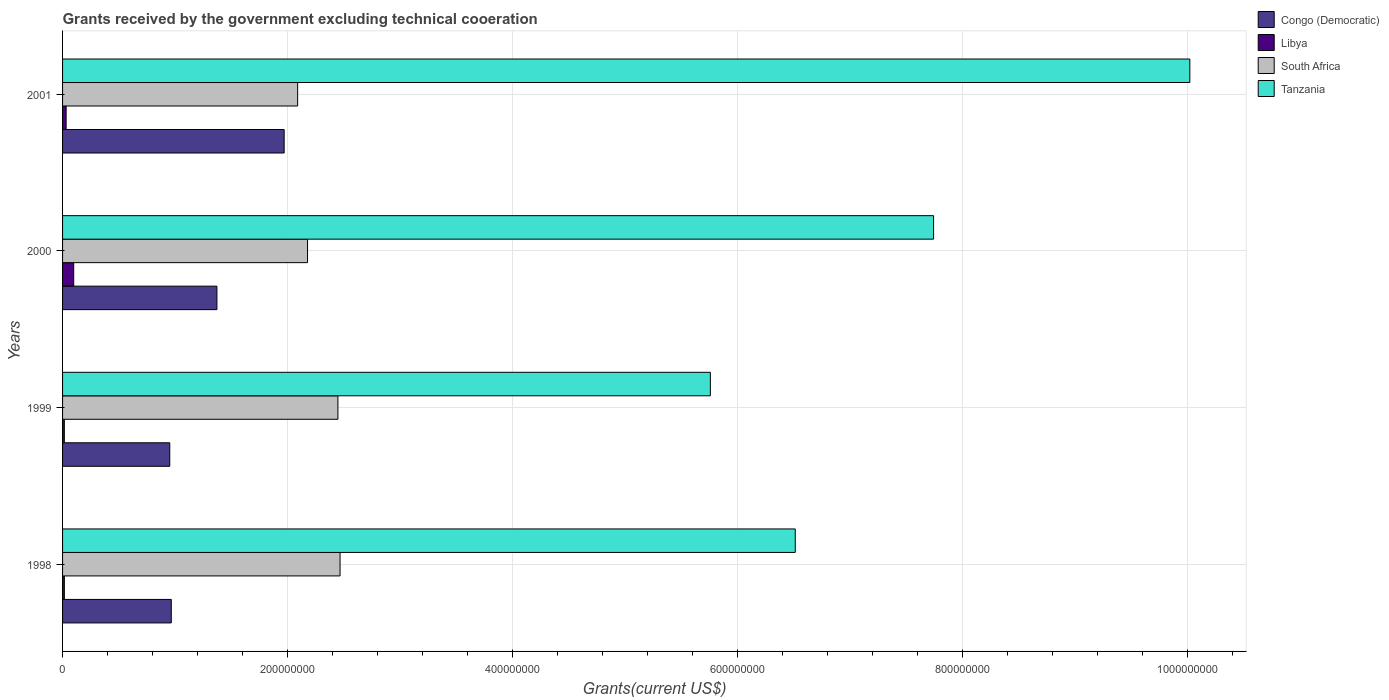How many groups of bars are there?
Offer a very short reply. 4. Are the number of bars per tick equal to the number of legend labels?
Offer a very short reply. Yes. How many bars are there on the 2nd tick from the top?
Offer a very short reply. 4. In how many cases, is the number of bars for a given year not equal to the number of legend labels?
Make the answer very short. 0. What is the total grants received by the government in Libya in 1999?
Ensure brevity in your answer.  1.57e+06. Across all years, what is the maximum total grants received by the government in Tanzania?
Offer a very short reply. 1.00e+09. Across all years, what is the minimum total grants received by the government in South Africa?
Make the answer very short. 2.09e+08. In which year was the total grants received by the government in Congo (Democratic) maximum?
Give a very brief answer. 2001. In which year was the total grants received by the government in Libya minimum?
Your response must be concise. 1999. What is the total total grants received by the government in Congo (Democratic) in the graph?
Provide a short and direct response. 5.26e+08. What is the difference between the total grants received by the government in Congo (Democratic) in 1999 and that in 2000?
Your response must be concise. -4.19e+07. What is the difference between the total grants received by the government in Congo (Democratic) in 1999 and the total grants received by the government in South Africa in 2001?
Provide a succinct answer. -1.14e+08. What is the average total grants received by the government in Libya per year?
Keep it short and to the point. 4.06e+06. In the year 1999, what is the difference between the total grants received by the government in Libya and total grants received by the government in Congo (Democratic)?
Provide a short and direct response. -9.37e+07. In how many years, is the total grants received by the government in Tanzania greater than 640000000 US$?
Your answer should be compact. 3. What is the ratio of the total grants received by the government in South Africa in 1999 to that in 2001?
Make the answer very short. 1.17. Is the difference between the total grants received by the government in Libya in 1999 and 2001 greater than the difference between the total grants received by the government in Congo (Democratic) in 1999 and 2001?
Keep it short and to the point. Yes. What is the difference between the highest and the second highest total grants received by the government in Congo (Democratic)?
Your answer should be very brief. 5.98e+07. What is the difference between the highest and the lowest total grants received by the government in Congo (Democratic)?
Your response must be concise. 1.02e+08. In how many years, is the total grants received by the government in Congo (Democratic) greater than the average total grants received by the government in Congo (Democratic) taken over all years?
Provide a succinct answer. 2. Is it the case that in every year, the sum of the total grants received by the government in Tanzania and total grants received by the government in Libya is greater than the sum of total grants received by the government in Congo (Democratic) and total grants received by the government in South Africa?
Offer a very short reply. Yes. What does the 1st bar from the top in 2000 represents?
Offer a very short reply. Tanzania. What does the 1st bar from the bottom in 1998 represents?
Make the answer very short. Congo (Democratic). Is it the case that in every year, the sum of the total grants received by the government in South Africa and total grants received by the government in Congo (Democratic) is greater than the total grants received by the government in Libya?
Make the answer very short. Yes. Are all the bars in the graph horizontal?
Provide a short and direct response. Yes. Does the graph contain any zero values?
Offer a very short reply. No. Does the graph contain grids?
Your answer should be compact. Yes. Where does the legend appear in the graph?
Offer a very short reply. Top right. What is the title of the graph?
Ensure brevity in your answer.  Grants received by the government excluding technical cooeration. Does "Madagascar" appear as one of the legend labels in the graph?
Your answer should be compact. No. What is the label or title of the X-axis?
Your answer should be very brief. Grants(current US$). What is the label or title of the Y-axis?
Make the answer very short. Years. What is the Grants(current US$) in Congo (Democratic) in 1998?
Keep it short and to the point. 9.67e+07. What is the Grants(current US$) in Libya in 1998?
Ensure brevity in your answer.  1.59e+06. What is the Grants(current US$) of South Africa in 1998?
Ensure brevity in your answer.  2.47e+08. What is the Grants(current US$) in Tanzania in 1998?
Offer a terse response. 6.51e+08. What is the Grants(current US$) of Congo (Democratic) in 1999?
Offer a terse response. 9.53e+07. What is the Grants(current US$) in Libya in 1999?
Your response must be concise. 1.57e+06. What is the Grants(current US$) in South Africa in 1999?
Your response must be concise. 2.45e+08. What is the Grants(current US$) of Tanzania in 1999?
Your answer should be compact. 5.76e+08. What is the Grants(current US$) of Congo (Democratic) in 2000?
Your answer should be compact. 1.37e+08. What is the Grants(current US$) in Libya in 2000?
Your response must be concise. 9.90e+06. What is the Grants(current US$) of South Africa in 2000?
Your answer should be very brief. 2.18e+08. What is the Grants(current US$) in Tanzania in 2000?
Offer a very short reply. 7.74e+08. What is the Grants(current US$) in Congo (Democratic) in 2001?
Ensure brevity in your answer.  1.97e+08. What is the Grants(current US$) in Libya in 2001?
Provide a short and direct response. 3.17e+06. What is the Grants(current US$) of South Africa in 2001?
Provide a succinct answer. 2.09e+08. What is the Grants(current US$) in Tanzania in 2001?
Give a very brief answer. 1.00e+09. Across all years, what is the maximum Grants(current US$) of Congo (Democratic)?
Your answer should be very brief. 1.97e+08. Across all years, what is the maximum Grants(current US$) of Libya?
Ensure brevity in your answer.  9.90e+06. Across all years, what is the maximum Grants(current US$) in South Africa?
Your answer should be very brief. 2.47e+08. Across all years, what is the maximum Grants(current US$) of Tanzania?
Provide a short and direct response. 1.00e+09. Across all years, what is the minimum Grants(current US$) of Congo (Democratic)?
Offer a terse response. 9.53e+07. Across all years, what is the minimum Grants(current US$) in Libya?
Make the answer very short. 1.57e+06. Across all years, what is the minimum Grants(current US$) of South Africa?
Offer a very short reply. 2.09e+08. Across all years, what is the minimum Grants(current US$) of Tanzania?
Ensure brevity in your answer.  5.76e+08. What is the total Grants(current US$) in Congo (Democratic) in the graph?
Make the answer very short. 5.26e+08. What is the total Grants(current US$) of Libya in the graph?
Keep it short and to the point. 1.62e+07. What is the total Grants(current US$) in South Africa in the graph?
Offer a very short reply. 9.18e+08. What is the total Grants(current US$) of Tanzania in the graph?
Make the answer very short. 3.00e+09. What is the difference between the Grants(current US$) in Congo (Democratic) in 1998 and that in 1999?
Your answer should be very brief. 1.35e+06. What is the difference between the Grants(current US$) of South Africa in 1998 and that in 1999?
Offer a terse response. 1.90e+06. What is the difference between the Grants(current US$) of Tanzania in 1998 and that in 1999?
Offer a very short reply. 7.55e+07. What is the difference between the Grants(current US$) in Congo (Democratic) in 1998 and that in 2000?
Offer a terse response. -4.06e+07. What is the difference between the Grants(current US$) of Libya in 1998 and that in 2000?
Keep it short and to the point. -8.31e+06. What is the difference between the Grants(current US$) of South Africa in 1998 and that in 2000?
Ensure brevity in your answer.  2.89e+07. What is the difference between the Grants(current US$) of Tanzania in 1998 and that in 2000?
Your response must be concise. -1.23e+08. What is the difference between the Grants(current US$) of Congo (Democratic) in 1998 and that in 2001?
Keep it short and to the point. -1.00e+08. What is the difference between the Grants(current US$) of Libya in 1998 and that in 2001?
Provide a short and direct response. -1.58e+06. What is the difference between the Grants(current US$) of South Africa in 1998 and that in 2001?
Give a very brief answer. 3.77e+07. What is the difference between the Grants(current US$) in Tanzania in 1998 and that in 2001?
Your answer should be compact. -3.51e+08. What is the difference between the Grants(current US$) in Congo (Democratic) in 1999 and that in 2000?
Your response must be concise. -4.19e+07. What is the difference between the Grants(current US$) in Libya in 1999 and that in 2000?
Provide a succinct answer. -8.33e+06. What is the difference between the Grants(current US$) in South Africa in 1999 and that in 2000?
Give a very brief answer. 2.70e+07. What is the difference between the Grants(current US$) in Tanzania in 1999 and that in 2000?
Your answer should be compact. -1.98e+08. What is the difference between the Grants(current US$) of Congo (Democratic) in 1999 and that in 2001?
Your answer should be compact. -1.02e+08. What is the difference between the Grants(current US$) of Libya in 1999 and that in 2001?
Provide a short and direct response. -1.60e+06. What is the difference between the Grants(current US$) in South Africa in 1999 and that in 2001?
Offer a very short reply. 3.58e+07. What is the difference between the Grants(current US$) of Tanzania in 1999 and that in 2001?
Ensure brevity in your answer.  -4.26e+08. What is the difference between the Grants(current US$) of Congo (Democratic) in 2000 and that in 2001?
Ensure brevity in your answer.  -5.98e+07. What is the difference between the Grants(current US$) in Libya in 2000 and that in 2001?
Offer a terse response. 6.73e+06. What is the difference between the Grants(current US$) in South Africa in 2000 and that in 2001?
Make the answer very short. 8.80e+06. What is the difference between the Grants(current US$) in Tanzania in 2000 and that in 2001?
Ensure brevity in your answer.  -2.28e+08. What is the difference between the Grants(current US$) in Congo (Democratic) in 1998 and the Grants(current US$) in Libya in 1999?
Give a very brief answer. 9.51e+07. What is the difference between the Grants(current US$) of Congo (Democratic) in 1998 and the Grants(current US$) of South Africa in 1999?
Your answer should be compact. -1.48e+08. What is the difference between the Grants(current US$) in Congo (Democratic) in 1998 and the Grants(current US$) in Tanzania in 1999?
Ensure brevity in your answer.  -4.79e+08. What is the difference between the Grants(current US$) of Libya in 1998 and the Grants(current US$) of South Africa in 1999?
Offer a very short reply. -2.43e+08. What is the difference between the Grants(current US$) of Libya in 1998 and the Grants(current US$) of Tanzania in 1999?
Offer a very short reply. -5.74e+08. What is the difference between the Grants(current US$) in South Africa in 1998 and the Grants(current US$) in Tanzania in 1999?
Your response must be concise. -3.29e+08. What is the difference between the Grants(current US$) in Congo (Democratic) in 1998 and the Grants(current US$) in Libya in 2000?
Offer a very short reply. 8.68e+07. What is the difference between the Grants(current US$) in Congo (Democratic) in 1998 and the Grants(current US$) in South Africa in 2000?
Keep it short and to the point. -1.21e+08. What is the difference between the Grants(current US$) in Congo (Democratic) in 1998 and the Grants(current US$) in Tanzania in 2000?
Offer a terse response. -6.78e+08. What is the difference between the Grants(current US$) in Libya in 1998 and the Grants(current US$) in South Africa in 2000?
Make the answer very short. -2.16e+08. What is the difference between the Grants(current US$) in Libya in 1998 and the Grants(current US$) in Tanzania in 2000?
Your answer should be compact. -7.73e+08. What is the difference between the Grants(current US$) in South Africa in 1998 and the Grants(current US$) in Tanzania in 2000?
Give a very brief answer. -5.28e+08. What is the difference between the Grants(current US$) of Congo (Democratic) in 1998 and the Grants(current US$) of Libya in 2001?
Offer a terse response. 9.35e+07. What is the difference between the Grants(current US$) in Congo (Democratic) in 1998 and the Grants(current US$) in South Africa in 2001?
Offer a very short reply. -1.12e+08. What is the difference between the Grants(current US$) of Congo (Democratic) in 1998 and the Grants(current US$) of Tanzania in 2001?
Give a very brief answer. -9.06e+08. What is the difference between the Grants(current US$) of Libya in 1998 and the Grants(current US$) of South Africa in 2001?
Provide a succinct answer. -2.07e+08. What is the difference between the Grants(current US$) of Libya in 1998 and the Grants(current US$) of Tanzania in 2001?
Make the answer very short. -1.00e+09. What is the difference between the Grants(current US$) of South Africa in 1998 and the Grants(current US$) of Tanzania in 2001?
Give a very brief answer. -7.56e+08. What is the difference between the Grants(current US$) of Congo (Democratic) in 1999 and the Grants(current US$) of Libya in 2000?
Offer a terse response. 8.54e+07. What is the difference between the Grants(current US$) in Congo (Democratic) in 1999 and the Grants(current US$) in South Africa in 2000?
Your answer should be very brief. -1.22e+08. What is the difference between the Grants(current US$) of Congo (Democratic) in 1999 and the Grants(current US$) of Tanzania in 2000?
Provide a succinct answer. -6.79e+08. What is the difference between the Grants(current US$) in Libya in 1999 and the Grants(current US$) in South Africa in 2000?
Your answer should be very brief. -2.16e+08. What is the difference between the Grants(current US$) in Libya in 1999 and the Grants(current US$) in Tanzania in 2000?
Make the answer very short. -7.73e+08. What is the difference between the Grants(current US$) of South Africa in 1999 and the Grants(current US$) of Tanzania in 2000?
Offer a terse response. -5.30e+08. What is the difference between the Grants(current US$) in Congo (Democratic) in 1999 and the Grants(current US$) in Libya in 2001?
Ensure brevity in your answer.  9.21e+07. What is the difference between the Grants(current US$) in Congo (Democratic) in 1999 and the Grants(current US$) in South Africa in 2001?
Your answer should be very brief. -1.14e+08. What is the difference between the Grants(current US$) of Congo (Democratic) in 1999 and the Grants(current US$) of Tanzania in 2001?
Your response must be concise. -9.07e+08. What is the difference between the Grants(current US$) in Libya in 1999 and the Grants(current US$) in South Africa in 2001?
Ensure brevity in your answer.  -2.07e+08. What is the difference between the Grants(current US$) of Libya in 1999 and the Grants(current US$) of Tanzania in 2001?
Offer a terse response. -1.00e+09. What is the difference between the Grants(current US$) of South Africa in 1999 and the Grants(current US$) of Tanzania in 2001?
Offer a terse response. -7.57e+08. What is the difference between the Grants(current US$) in Congo (Democratic) in 2000 and the Grants(current US$) in Libya in 2001?
Your answer should be very brief. 1.34e+08. What is the difference between the Grants(current US$) in Congo (Democratic) in 2000 and the Grants(current US$) in South Africa in 2001?
Give a very brief answer. -7.18e+07. What is the difference between the Grants(current US$) of Congo (Democratic) in 2000 and the Grants(current US$) of Tanzania in 2001?
Offer a very short reply. -8.65e+08. What is the difference between the Grants(current US$) in Libya in 2000 and the Grants(current US$) in South Africa in 2001?
Offer a very short reply. -1.99e+08. What is the difference between the Grants(current US$) of Libya in 2000 and the Grants(current US$) of Tanzania in 2001?
Offer a very short reply. -9.92e+08. What is the difference between the Grants(current US$) in South Africa in 2000 and the Grants(current US$) in Tanzania in 2001?
Offer a terse response. -7.84e+08. What is the average Grants(current US$) in Congo (Democratic) per year?
Provide a succinct answer. 1.32e+08. What is the average Grants(current US$) in Libya per year?
Your answer should be compact. 4.06e+06. What is the average Grants(current US$) of South Africa per year?
Make the answer very short. 2.30e+08. What is the average Grants(current US$) in Tanzania per year?
Give a very brief answer. 7.51e+08. In the year 1998, what is the difference between the Grants(current US$) in Congo (Democratic) and Grants(current US$) in Libya?
Your answer should be very brief. 9.51e+07. In the year 1998, what is the difference between the Grants(current US$) of Congo (Democratic) and Grants(current US$) of South Africa?
Provide a succinct answer. -1.50e+08. In the year 1998, what is the difference between the Grants(current US$) in Congo (Democratic) and Grants(current US$) in Tanzania?
Your answer should be very brief. -5.55e+08. In the year 1998, what is the difference between the Grants(current US$) of Libya and Grants(current US$) of South Africa?
Ensure brevity in your answer.  -2.45e+08. In the year 1998, what is the difference between the Grants(current US$) in Libya and Grants(current US$) in Tanzania?
Keep it short and to the point. -6.50e+08. In the year 1998, what is the difference between the Grants(current US$) in South Africa and Grants(current US$) in Tanzania?
Ensure brevity in your answer.  -4.05e+08. In the year 1999, what is the difference between the Grants(current US$) in Congo (Democratic) and Grants(current US$) in Libya?
Provide a short and direct response. 9.37e+07. In the year 1999, what is the difference between the Grants(current US$) of Congo (Democratic) and Grants(current US$) of South Africa?
Your response must be concise. -1.50e+08. In the year 1999, what is the difference between the Grants(current US$) in Congo (Democratic) and Grants(current US$) in Tanzania?
Make the answer very short. -4.81e+08. In the year 1999, what is the difference between the Grants(current US$) in Libya and Grants(current US$) in South Africa?
Ensure brevity in your answer.  -2.43e+08. In the year 1999, what is the difference between the Grants(current US$) in Libya and Grants(current US$) in Tanzania?
Provide a succinct answer. -5.74e+08. In the year 1999, what is the difference between the Grants(current US$) in South Africa and Grants(current US$) in Tanzania?
Provide a succinct answer. -3.31e+08. In the year 2000, what is the difference between the Grants(current US$) of Congo (Democratic) and Grants(current US$) of Libya?
Keep it short and to the point. 1.27e+08. In the year 2000, what is the difference between the Grants(current US$) in Congo (Democratic) and Grants(current US$) in South Africa?
Offer a very short reply. -8.06e+07. In the year 2000, what is the difference between the Grants(current US$) in Congo (Democratic) and Grants(current US$) in Tanzania?
Your response must be concise. -6.37e+08. In the year 2000, what is the difference between the Grants(current US$) in Libya and Grants(current US$) in South Africa?
Make the answer very short. -2.08e+08. In the year 2000, what is the difference between the Grants(current US$) of Libya and Grants(current US$) of Tanzania?
Your answer should be very brief. -7.65e+08. In the year 2000, what is the difference between the Grants(current US$) of South Africa and Grants(current US$) of Tanzania?
Your answer should be very brief. -5.57e+08. In the year 2001, what is the difference between the Grants(current US$) of Congo (Democratic) and Grants(current US$) of Libya?
Your answer should be compact. 1.94e+08. In the year 2001, what is the difference between the Grants(current US$) of Congo (Democratic) and Grants(current US$) of South Africa?
Your response must be concise. -1.20e+07. In the year 2001, what is the difference between the Grants(current US$) in Congo (Democratic) and Grants(current US$) in Tanzania?
Make the answer very short. -8.05e+08. In the year 2001, what is the difference between the Grants(current US$) in Libya and Grants(current US$) in South Africa?
Your answer should be compact. -2.06e+08. In the year 2001, what is the difference between the Grants(current US$) in Libya and Grants(current US$) in Tanzania?
Your answer should be compact. -9.99e+08. In the year 2001, what is the difference between the Grants(current US$) of South Africa and Grants(current US$) of Tanzania?
Keep it short and to the point. -7.93e+08. What is the ratio of the Grants(current US$) in Congo (Democratic) in 1998 to that in 1999?
Give a very brief answer. 1.01. What is the ratio of the Grants(current US$) in Libya in 1998 to that in 1999?
Keep it short and to the point. 1.01. What is the ratio of the Grants(current US$) in Tanzania in 1998 to that in 1999?
Keep it short and to the point. 1.13. What is the ratio of the Grants(current US$) in Congo (Democratic) in 1998 to that in 2000?
Keep it short and to the point. 0.7. What is the ratio of the Grants(current US$) in Libya in 1998 to that in 2000?
Give a very brief answer. 0.16. What is the ratio of the Grants(current US$) in South Africa in 1998 to that in 2000?
Your answer should be very brief. 1.13. What is the ratio of the Grants(current US$) of Tanzania in 1998 to that in 2000?
Keep it short and to the point. 0.84. What is the ratio of the Grants(current US$) of Congo (Democratic) in 1998 to that in 2001?
Your answer should be very brief. 0.49. What is the ratio of the Grants(current US$) in Libya in 1998 to that in 2001?
Keep it short and to the point. 0.5. What is the ratio of the Grants(current US$) in South Africa in 1998 to that in 2001?
Provide a short and direct response. 1.18. What is the ratio of the Grants(current US$) of Tanzania in 1998 to that in 2001?
Offer a very short reply. 0.65. What is the ratio of the Grants(current US$) in Congo (Democratic) in 1999 to that in 2000?
Your answer should be very brief. 0.69. What is the ratio of the Grants(current US$) in Libya in 1999 to that in 2000?
Give a very brief answer. 0.16. What is the ratio of the Grants(current US$) of South Africa in 1999 to that in 2000?
Your answer should be compact. 1.12. What is the ratio of the Grants(current US$) in Tanzania in 1999 to that in 2000?
Your answer should be compact. 0.74. What is the ratio of the Grants(current US$) of Congo (Democratic) in 1999 to that in 2001?
Your answer should be compact. 0.48. What is the ratio of the Grants(current US$) in Libya in 1999 to that in 2001?
Offer a terse response. 0.5. What is the ratio of the Grants(current US$) of South Africa in 1999 to that in 2001?
Offer a very short reply. 1.17. What is the ratio of the Grants(current US$) in Tanzania in 1999 to that in 2001?
Offer a terse response. 0.57. What is the ratio of the Grants(current US$) in Congo (Democratic) in 2000 to that in 2001?
Your answer should be compact. 0.7. What is the ratio of the Grants(current US$) of Libya in 2000 to that in 2001?
Your response must be concise. 3.12. What is the ratio of the Grants(current US$) in South Africa in 2000 to that in 2001?
Your answer should be very brief. 1.04. What is the ratio of the Grants(current US$) of Tanzania in 2000 to that in 2001?
Your answer should be very brief. 0.77. What is the difference between the highest and the second highest Grants(current US$) of Congo (Democratic)?
Provide a succinct answer. 5.98e+07. What is the difference between the highest and the second highest Grants(current US$) of Libya?
Ensure brevity in your answer.  6.73e+06. What is the difference between the highest and the second highest Grants(current US$) in South Africa?
Provide a succinct answer. 1.90e+06. What is the difference between the highest and the second highest Grants(current US$) in Tanzania?
Your answer should be compact. 2.28e+08. What is the difference between the highest and the lowest Grants(current US$) in Congo (Democratic)?
Provide a succinct answer. 1.02e+08. What is the difference between the highest and the lowest Grants(current US$) of Libya?
Your answer should be very brief. 8.33e+06. What is the difference between the highest and the lowest Grants(current US$) of South Africa?
Provide a succinct answer. 3.77e+07. What is the difference between the highest and the lowest Grants(current US$) of Tanzania?
Make the answer very short. 4.26e+08. 